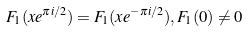Convert formula to latex. <formula><loc_0><loc_0><loc_500><loc_500>F _ { 1 } ( x e ^ { \pi i / 2 } ) = F _ { 1 } ( x e ^ { - \pi i / 2 } ) , F _ { 1 } ( 0 ) \ne 0</formula> 